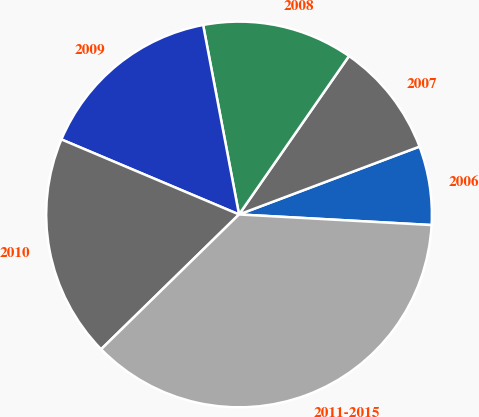<chart> <loc_0><loc_0><loc_500><loc_500><pie_chart><fcel>2006<fcel>2007<fcel>2008<fcel>2009<fcel>2010<fcel>2011-2015<nl><fcel>6.6%<fcel>9.62%<fcel>12.64%<fcel>15.66%<fcel>18.68%<fcel>36.81%<nl></chart> 